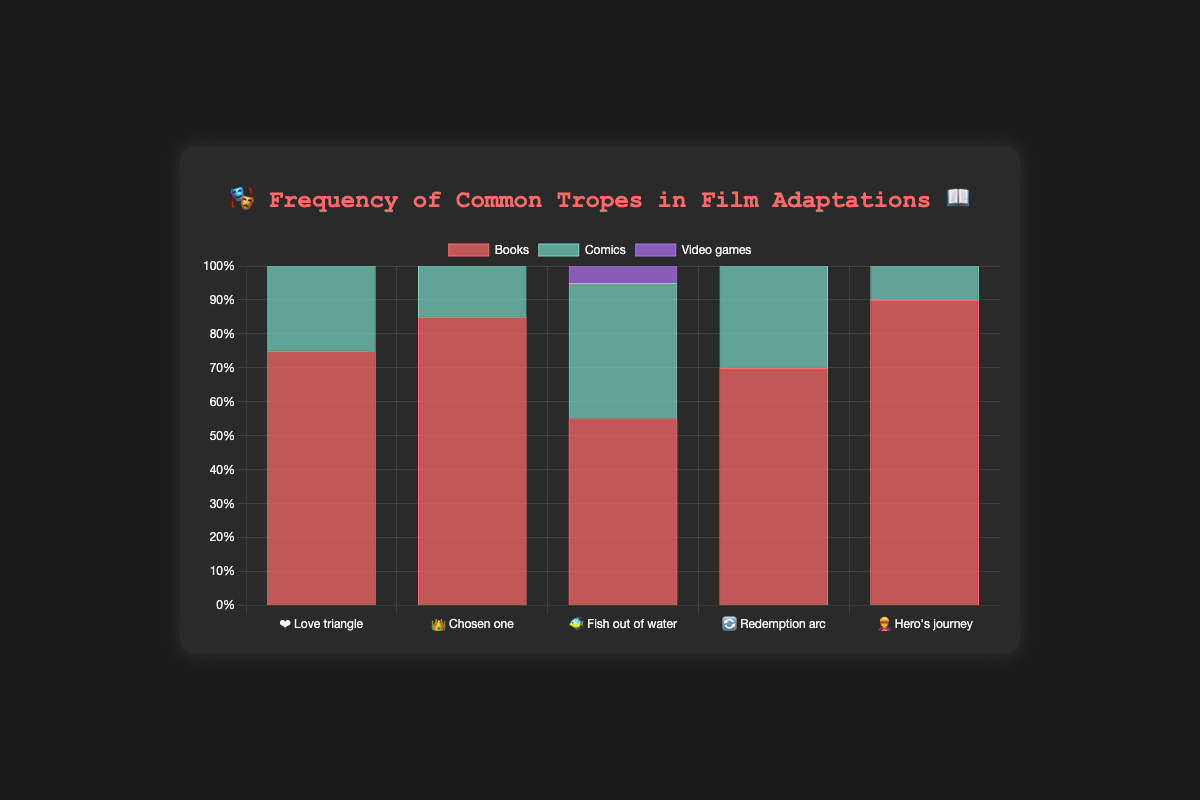What's the frequency of the "Chosen one" trope in books? The frequency of each trope by source material can be identified by looking at the respective bar in the chart. For "Chosen one" in books, the bar shows 85%.
Answer: 85% Which trope has the highest frequency in video games? We need to find the tallest bar for the video games data series. The tallest bar is for the "Chosen one" trope at 80%.
Answer: "Chosen one" 👑 What is the median frequency of the "Love triangle" trope across all sources? The values for "Love triangle" in books, comics, and video games are 75%, 60%, and 45%. Arranging them in order: 45%, 60%, 75%. The middle value is 60%.
Answer: 60% Which source material features the "Redemption arc" trope the most frequently? Compare the bars for each source material ("Books," "Comics," and "Video games") for the "Redemption arc" trope. The highest bar is for "Comics" at 80%.
Answer: Comics Is the "Hero's journey" trope more common in books or comics? Compare the bars for "Books" and "Comics" for the "Hero's journey" trope. "Books" has a frequency of 90%, and "Comics" has a frequency of 85%.
Answer: Books What is the difference in frequency of the "Fish out of water" trope between books and comics? The frequencies for "Fish out of water" are 55% for books and 40% for comics. The difference is 55% - 40% = 15%.
Answer: 15% Which trope has the least variance across all source materials? To determine variance, we compare the spread of frequencies for each trope across books, comics, and video games. "Chosen one" with 85%, 70%, and 80% has the smallest range (85% - 70% = 15%).
Answer: "Chosen one" 👑 How do the total frequencies of the "Love triangle" and "Hero's journey" tropes in video games compare? Summing the frequencies of "Love triangle" (45%) and "Hero's journey" (75%) in video games gives 45% + 75% = 120%. Both individually and in combination, we find the separate values directly from the chart.
Answer: Both summed and separately as shown Which trope in comics has the closest frequency to the "Fish out of water" trope in video games? "Fish out of water" in video games has a frequency of 65%. The closest equivalent in comics is "Love triangle" at 60%.
Answer: "Love triangle" ❤️ 